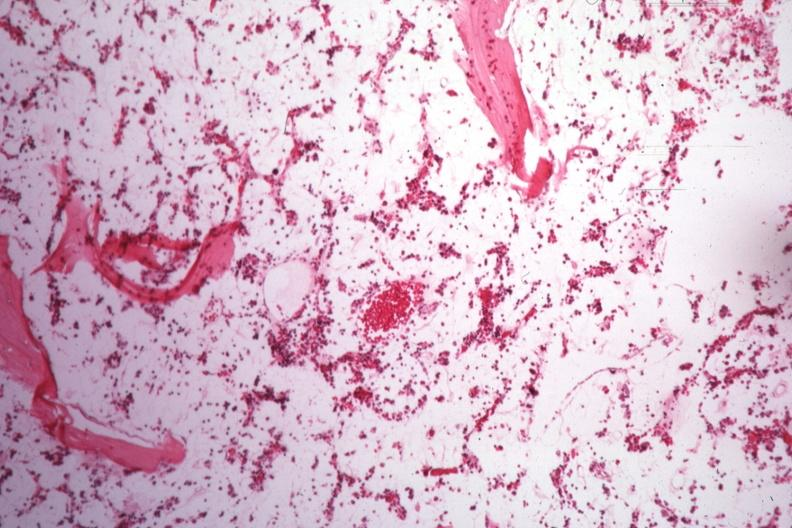s acrocyanosis present?
Answer the question using a single word or phrase. No 